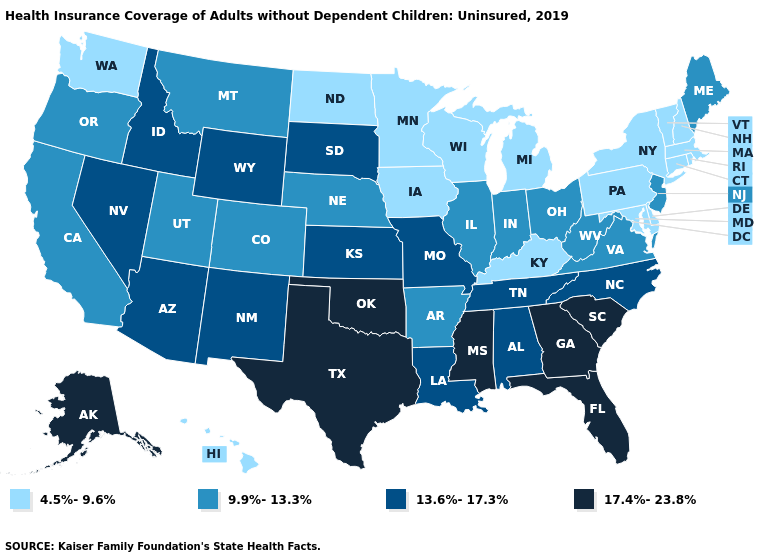What is the value of Connecticut?
Quick response, please. 4.5%-9.6%. What is the lowest value in the USA?
Short answer required. 4.5%-9.6%. Does South Carolina have a higher value than Georgia?
Write a very short answer. No. Name the states that have a value in the range 13.6%-17.3%?
Be succinct. Alabama, Arizona, Idaho, Kansas, Louisiana, Missouri, Nevada, New Mexico, North Carolina, South Dakota, Tennessee, Wyoming. Which states have the lowest value in the Northeast?
Answer briefly. Connecticut, Massachusetts, New Hampshire, New York, Pennsylvania, Rhode Island, Vermont. Which states hav the highest value in the West?
Be succinct. Alaska. Name the states that have a value in the range 9.9%-13.3%?
Concise answer only. Arkansas, California, Colorado, Illinois, Indiana, Maine, Montana, Nebraska, New Jersey, Ohio, Oregon, Utah, Virginia, West Virginia. What is the highest value in states that border New Jersey?
Answer briefly. 4.5%-9.6%. What is the highest value in the USA?
Quick response, please. 17.4%-23.8%. What is the value of North Dakota?
Be succinct. 4.5%-9.6%. Name the states that have a value in the range 13.6%-17.3%?
Keep it brief. Alabama, Arizona, Idaho, Kansas, Louisiana, Missouri, Nevada, New Mexico, North Carolina, South Dakota, Tennessee, Wyoming. Name the states that have a value in the range 4.5%-9.6%?
Short answer required. Connecticut, Delaware, Hawaii, Iowa, Kentucky, Maryland, Massachusetts, Michigan, Minnesota, New Hampshire, New York, North Dakota, Pennsylvania, Rhode Island, Vermont, Washington, Wisconsin. Name the states that have a value in the range 13.6%-17.3%?
Be succinct. Alabama, Arizona, Idaho, Kansas, Louisiana, Missouri, Nevada, New Mexico, North Carolina, South Dakota, Tennessee, Wyoming. What is the highest value in the South ?
Concise answer only. 17.4%-23.8%. What is the value of Nebraska?
Be succinct. 9.9%-13.3%. 